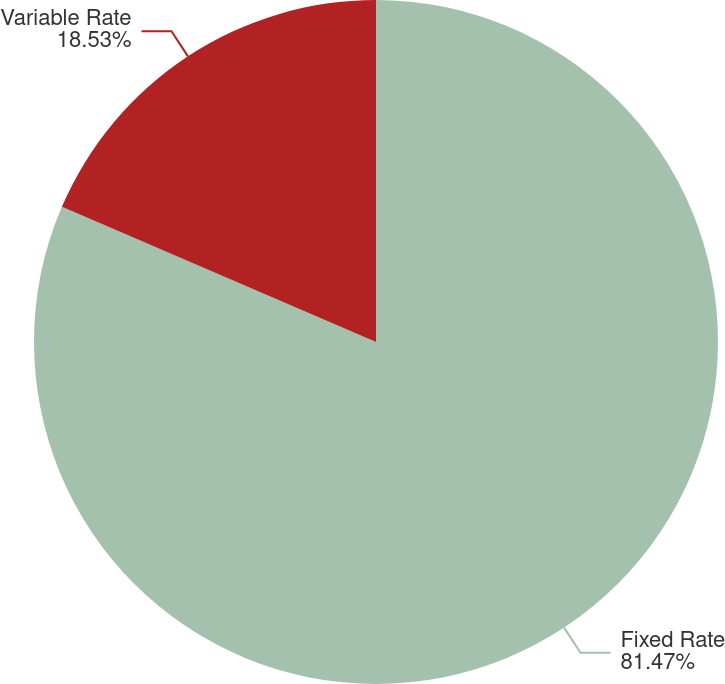<chart> <loc_0><loc_0><loc_500><loc_500><pie_chart><fcel>Fixed Rate<fcel>Variable Rate<nl><fcel>81.47%<fcel>18.53%<nl></chart> 